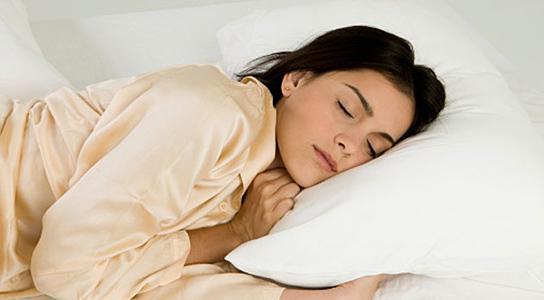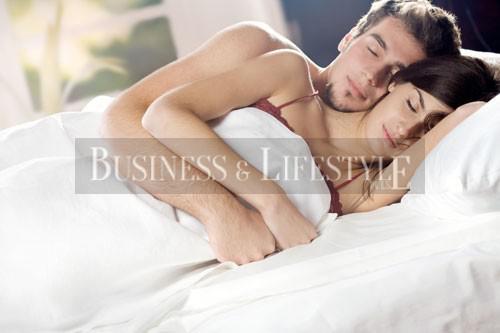The first image is the image on the left, the second image is the image on the right. Given the left and right images, does the statement "There is no less than one sleeping woman visible" hold true? Answer yes or no. Yes. The first image is the image on the left, the second image is the image on the right. Evaluate the accuracy of this statement regarding the images: "there are humans sleeping". Is it true? Answer yes or no. Yes. 